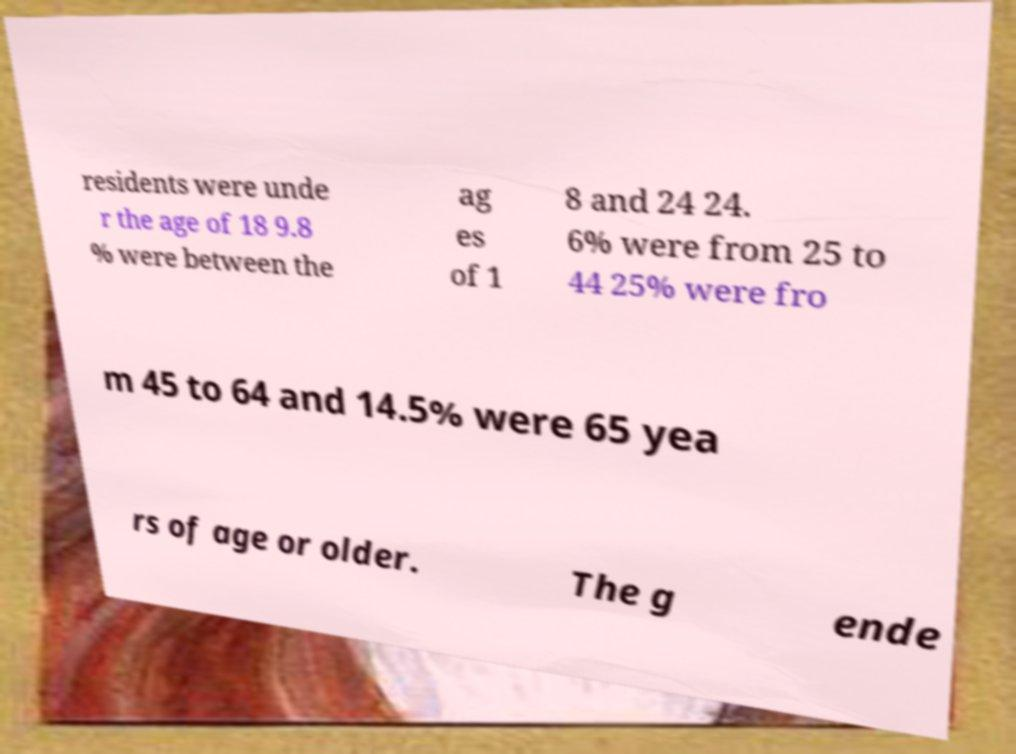There's text embedded in this image that I need extracted. Can you transcribe it verbatim? residents were unde r the age of 18 9.8 % were between the ag es of 1 8 and 24 24. 6% were from 25 to 44 25% were fro m 45 to 64 and 14.5% were 65 yea rs of age or older. The g ende 